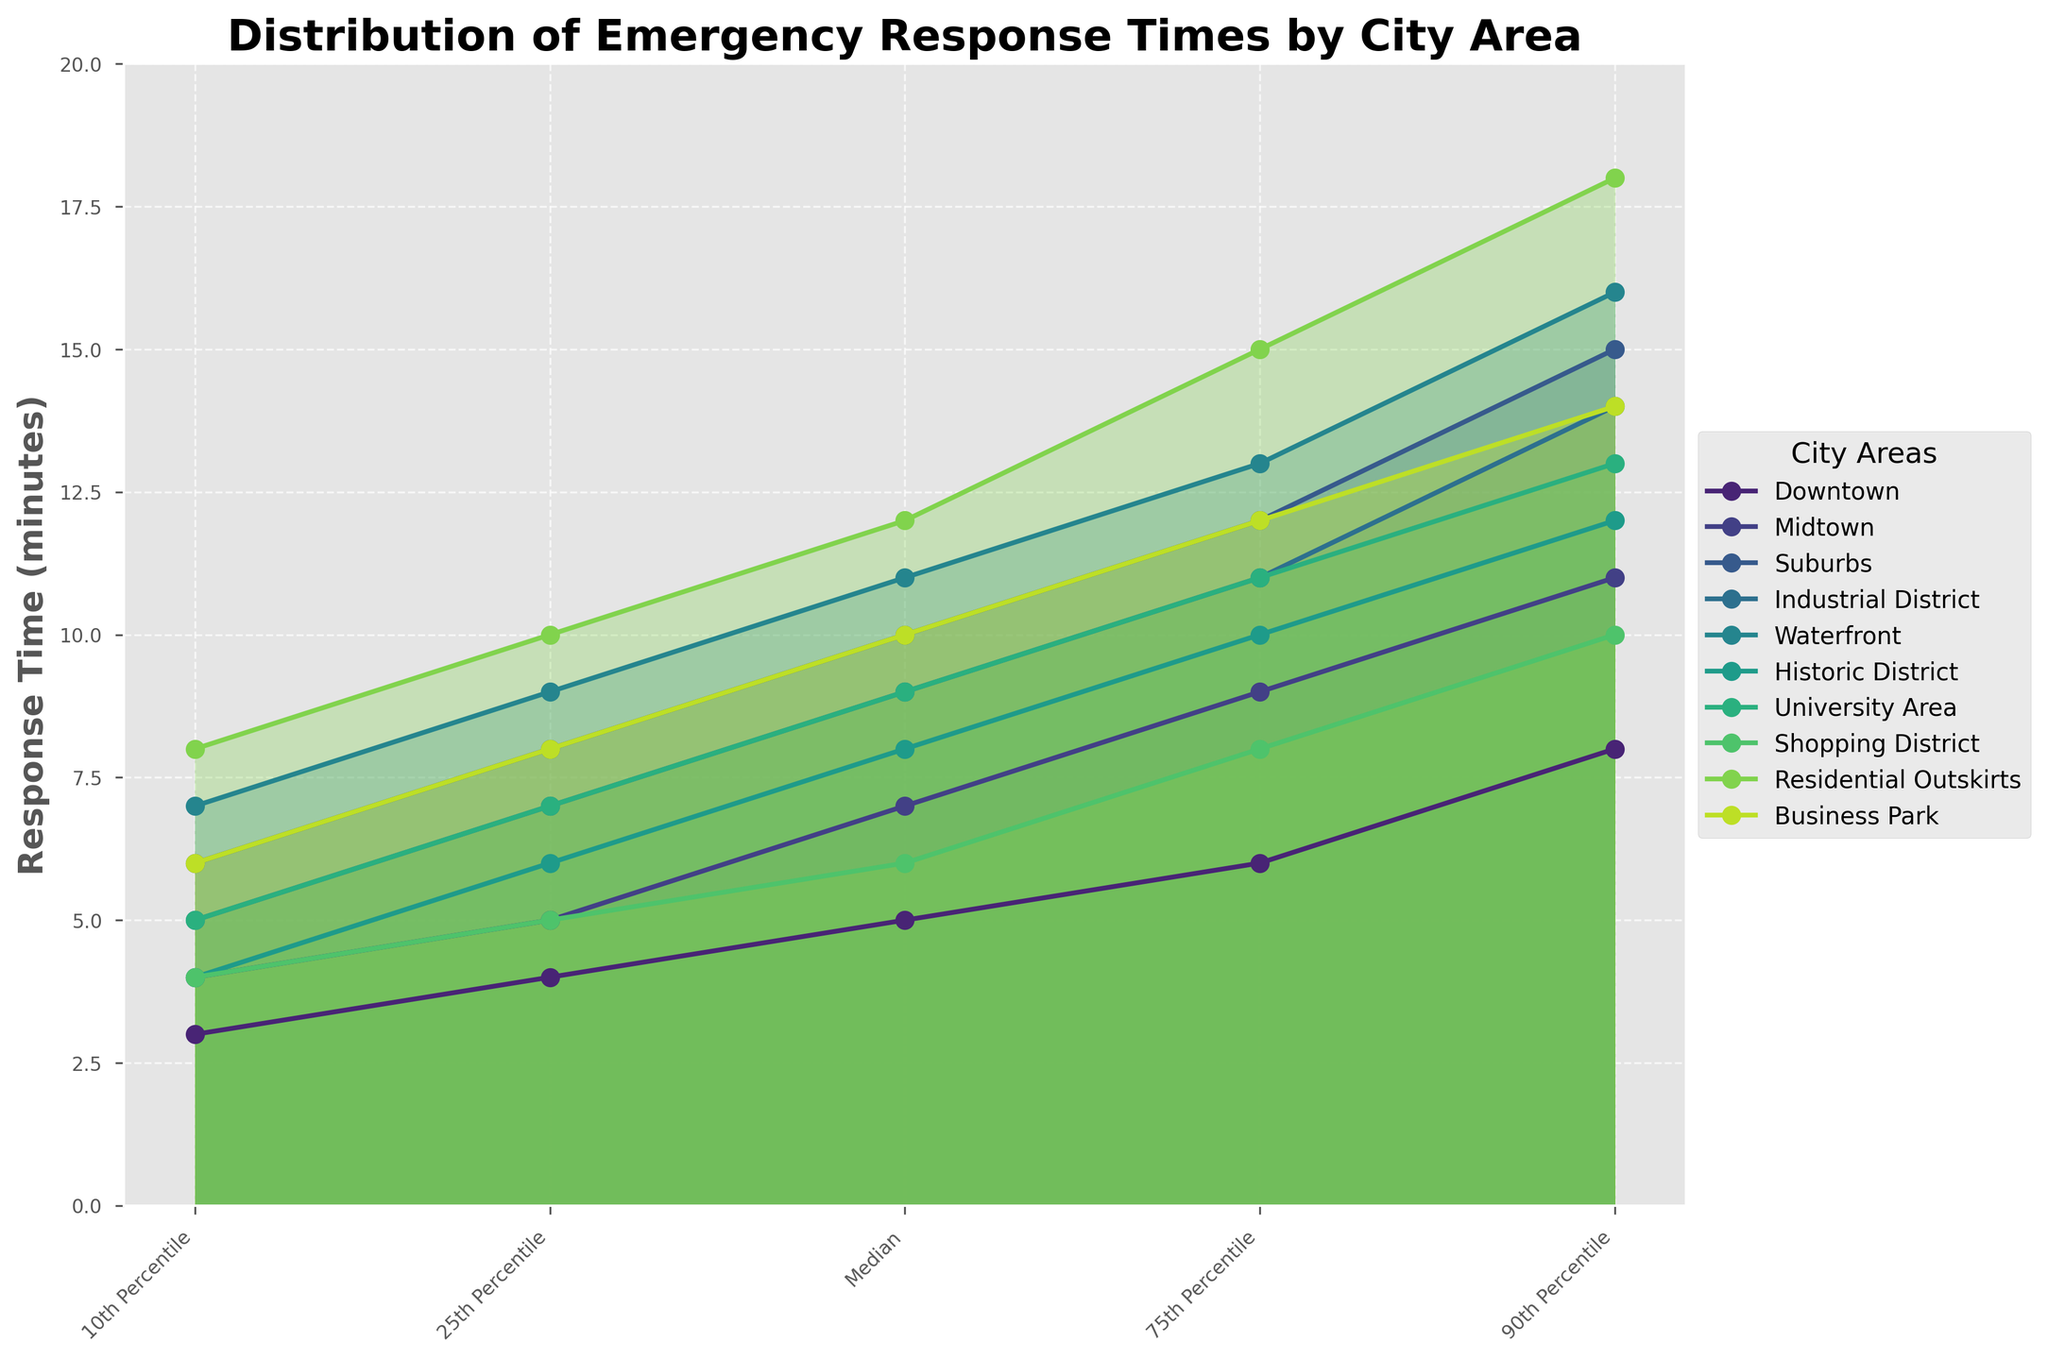what is the title of the figure? The title of the figure is located at the top of the chart, written in a larger, bold font to clearly indicate the content of the chart.
Answer: Distribution of Emergency Response Times by City Area what does the y-axis represent? The y-axis, labeled with bold text, represents the response time in minutes.
Answer: Response Time (minutes) which area has the fastest median response time? To find the fastest median response time, identify the median values for all the areas and determine which is the smallest. Downtown has a median response time of 5 minutes, which is the fastest.
Answer: Downtown which area has the slowest 90th percentile response time? Compare the 90th percentile values for all areas and find the highest value. Residential Outskirts has the slowest 90th percentile response time with 18 minutes.
Answer: Residential Outskirts how do response times in the Suburbs compare to those in the Business Park at the 75th percentile? Look at the 75th percentile values for both the Suburbs (12 minutes) and the Business Park (12 minutes). Both areas have the same response time at the 75th percentile.
Answer: Suburbs and Business Park have equal response times which area shows the largest spread between the 10th and 90th percentiles? Calculate the spread by subtracting the 10th percentile from the 90th percentile for each area and identify the largest difference. Residential Outskirts has the largest spread: 18 - 8 = 10 minutes.
Answer: Residential Outskirts do any areas have overlapping ranges in response times? To determine overlapping ranges, compare the percentile ranges for different areas visually. The Midtown and the Industrial District overlap significantly in their response times.
Answer: Yes, Midtown and Industrial District which two areas have the most similar distribution of response times across all percentiles? Assess the similarity in patterns and values across the percentiles for all areas. The Business Park and Industrial District have very similar distributions, sharing many common percentile values.
Answer: Business Park and Industrial District what trend is apparent in the distribution of the Residential Outskirts' response times? Examine the response times for the Residential Outskirts by observing how the times increase from the 10th percentile to the 90th percentile. The response times in the Residential Outskirts show a consistent increase, indicating a predictable and wide range in emergency response times.
Answer: Consistent increase overall, which area generally has the slowest response times? Identify the highest median and other percentile values among the areas. Residential Outskirts generally has the slowest response times across multiple percentiles.
Answer: Residential Outskirts 